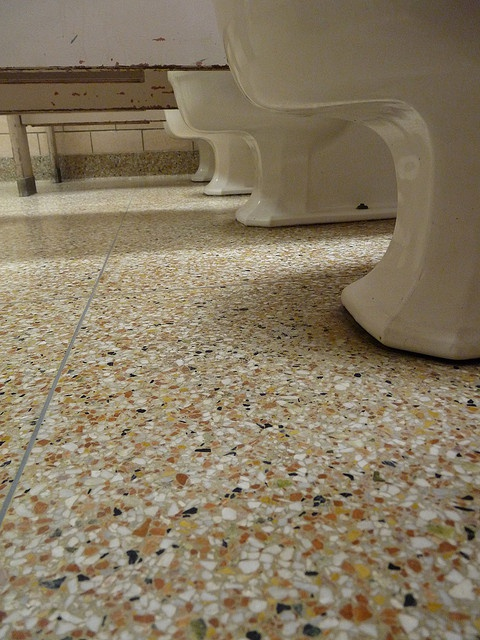Describe the objects in this image and their specific colors. I can see toilet in gray tones, toilet in gray tones, toilet in gray and darkgray tones, and toilet in gray tones in this image. 